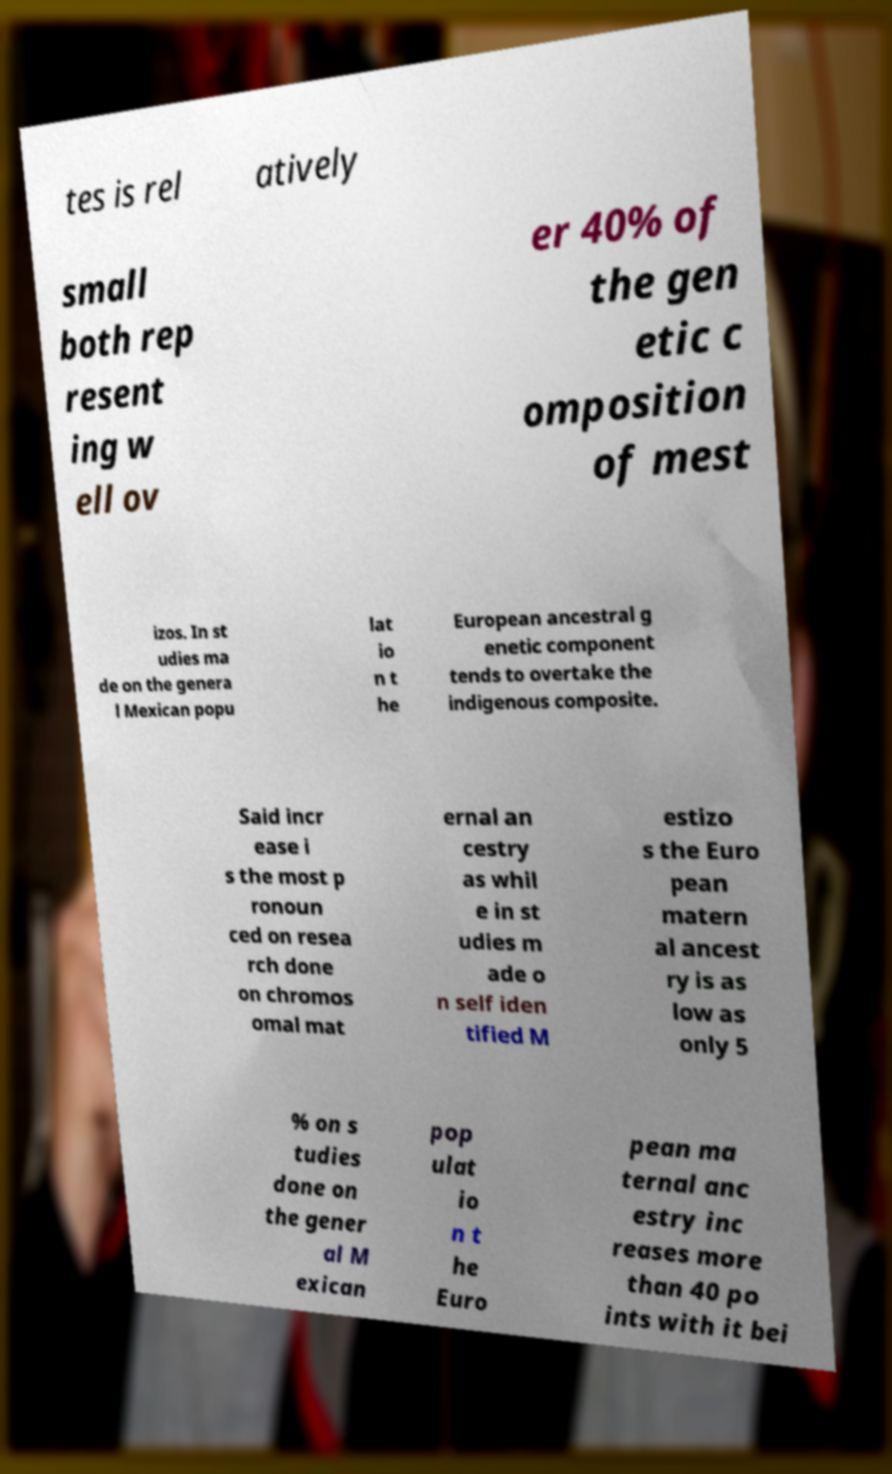Can you read and provide the text displayed in the image?This photo seems to have some interesting text. Can you extract and type it out for me? tes is rel atively small both rep resent ing w ell ov er 40% of the gen etic c omposition of mest izos. In st udies ma de on the genera l Mexican popu lat io n t he European ancestral g enetic component tends to overtake the indigenous composite. Said incr ease i s the most p ronoun ced on resea rch done on chromos omal mat ernal an cestry as whil e in st udies m ade o n self iden tified M estizo s the Euro pean matern al ancest ry is as low as only 5 % on s tudies done on the gener al M exican pop ulat io n t he Euro pean ma ternal anc estry inc reases more than 40 po ints with it bei 